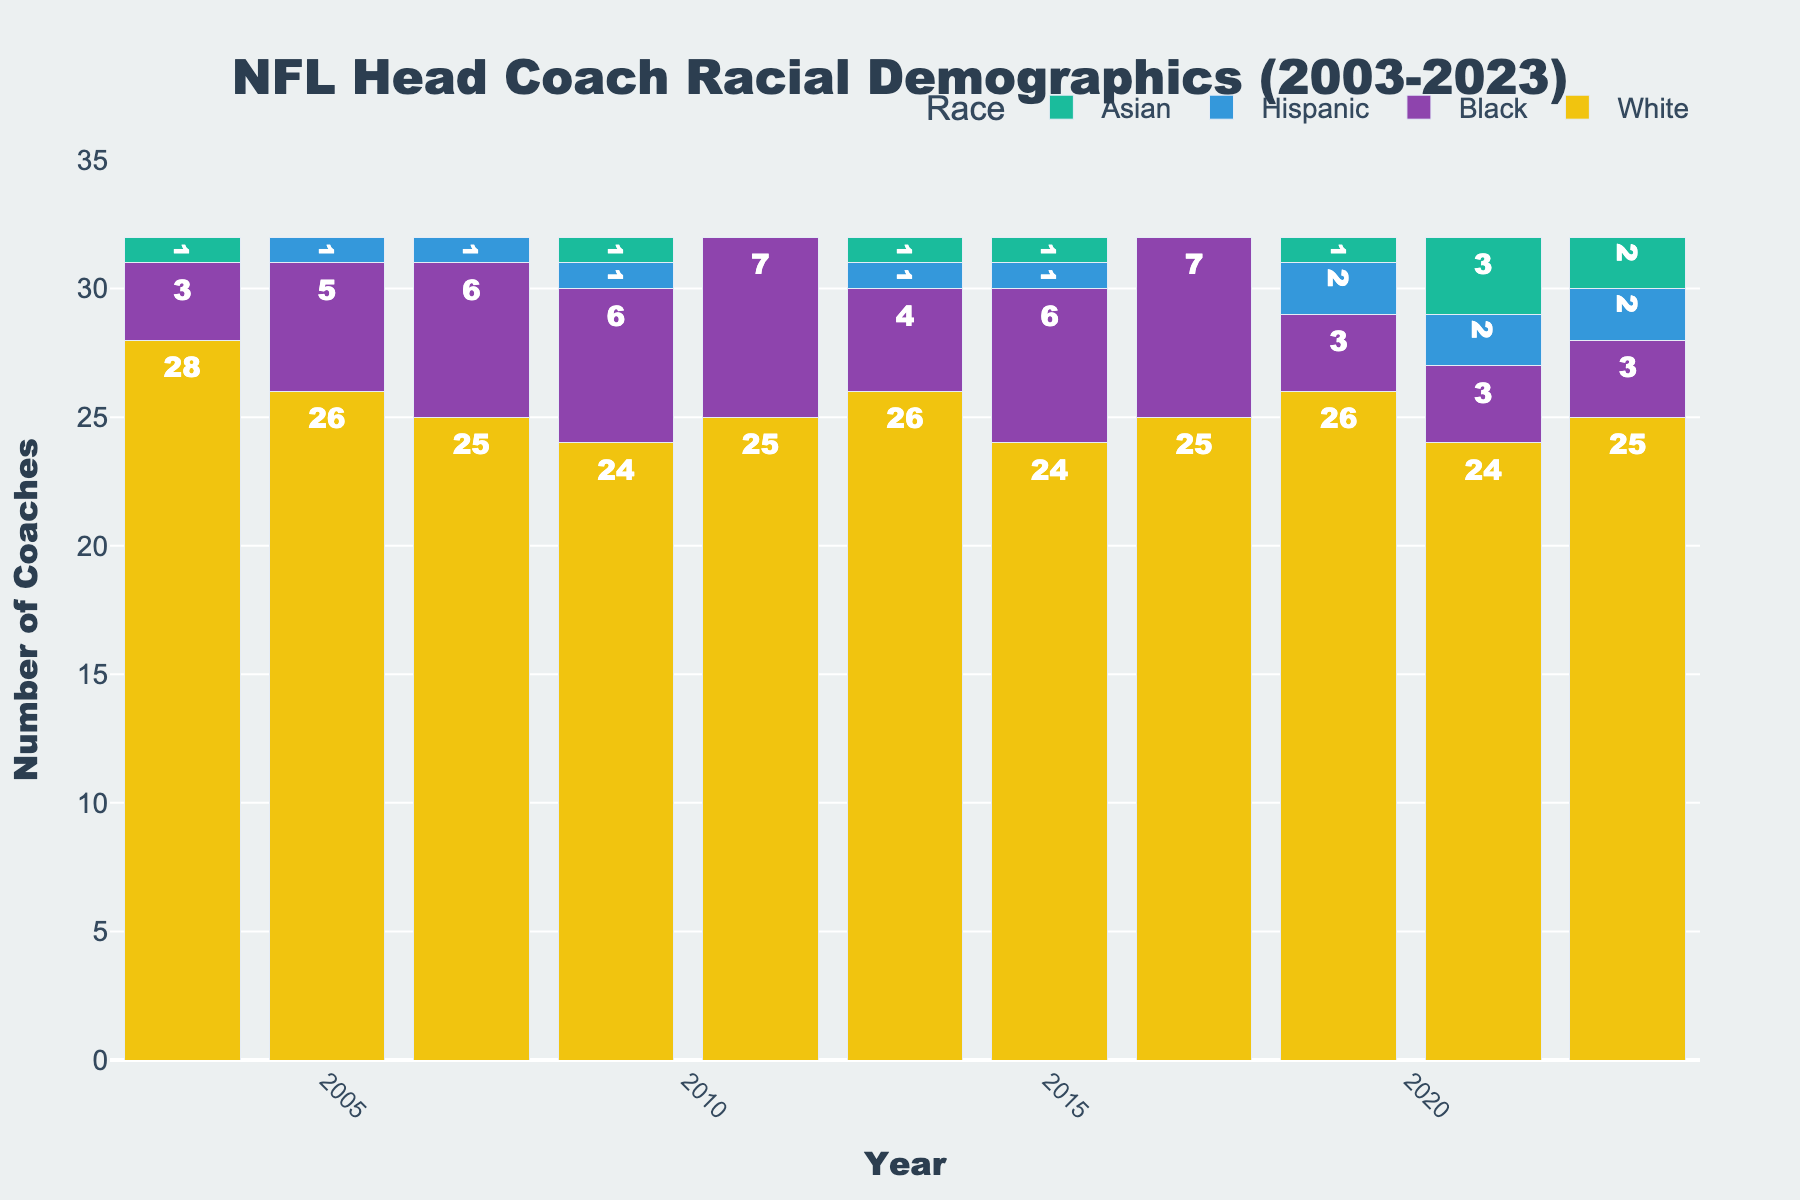What's the total number of NFL head coaches in 2023? To find the total number of NFL head coaches in 2023, sum up the values of all racial categories for the year 2023: 25 (White) + 3 (Black) + 2 (Hispanic) + 2 (Asian) = 32.
Answer: 32 Which year had the highest number of Black NFL head coaches, and how many were there? Look for the tallest bar segment colored in the color representing Black, then identify the year and the count. The highest count of Black NFL head coaches was in 2011, with a count of 7.
Answer: 2011, 7 How did the number of Hispanic head coaches change from 2003 to 2023? Compare the values for Hispanic head coaches in 2003 and 2023: In 2003, there were 0 Hispanic head coaches, and in 2023, there were 2 Hispanic head coaches.
Answer: Increased by 2 What is the difference in the number of White NFL head coaches between 2003 and 2023? Subtract the number of White head coaches in 2023 from the number of White head coaches in 2003: 28 (in 2003) - 25 (in 2023) = 3.
Answer: 3 Which racial group saw the most significant increase in the number of head coaches from 2003 to 2023? Compare the increase in each racial group's head coaches from 2003 to 2023. White: 28 to 25 (-3), Black: 3 to 3 (0), Hispanic: 0 to 2 (+2), Asian: 1 to 2 (+1). Hispanic head coaches saw the most significant increase.
Answer: Hispanic Did any year have no Asian NFL head coaches? If so, which year(s)? Identify the years with 0 in the Asian category: 2005, 2007, 2011, and 2017 are the years with no Asian NFL head coaches.
Answer: 2005, 2007, 2011, 2017 What is the trend in the number of Asian NFL head coaches from 2009 to 2023? Look for the count of Asian head coaches in the specified years: 2009 (1), 2013 (1), 2015 (1), 2019 (1), 2021 (3), and 2023 (2). There's an overall increasing trend with fluctuation.
Answer: Increasing with fluctuation How many years have the number of White head coaches remain constant within the given timeframe? Identify the years where the count of White head coaches did not change: 2005-2007 (26), 2011-2013 (25), and 2021-2023 (25). So, there are 2 periods with constant counts making it a total of 4 years of constancy.
Answer: 4 